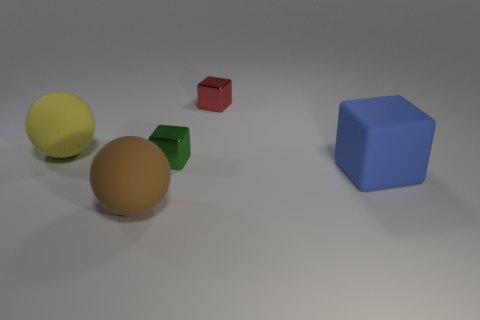What shape is the brown rubber thing in front of the blue rubber cube?
Provide a succinct answer. Sphere. The yellow rubber object that is the same size as the blue cube is what shape?
Make the answer very short. Sphere. What is the color of the small object on the right side of the metal thing that is in front of the big matte thing behind the blue rubber thing?
Ensure brevity in your answer.  Red. Do the large yellow thing and the big brown matte object have the same shape?
Offer a terse response. Yes. Are there an equal number of rubber cubes that are to the left of the red cube and big brown matte spheres?
Make the answer very short. No. What number of other things are there of the same material as the green block
Give a very brief answer. 1. There is a sphere that is in front of the large yellow matte ball; is its size the same as the blue object that is behind the big brown rubber sphere?
Offer a very short reply. Yes. What number of things are either large matte objects to the right of the large brown matte thing or rubber spheres that are to the right of the large yellow matte object?
Your answer should be compact. 2. Is there any other thing that has the same shape as the small red object?
Provide a succinct answer. Yes. There is a big sphere that is behind the large blue object; does it have the same color as the cube that is right of the tiny red block?
Your answer should be compact. No. 